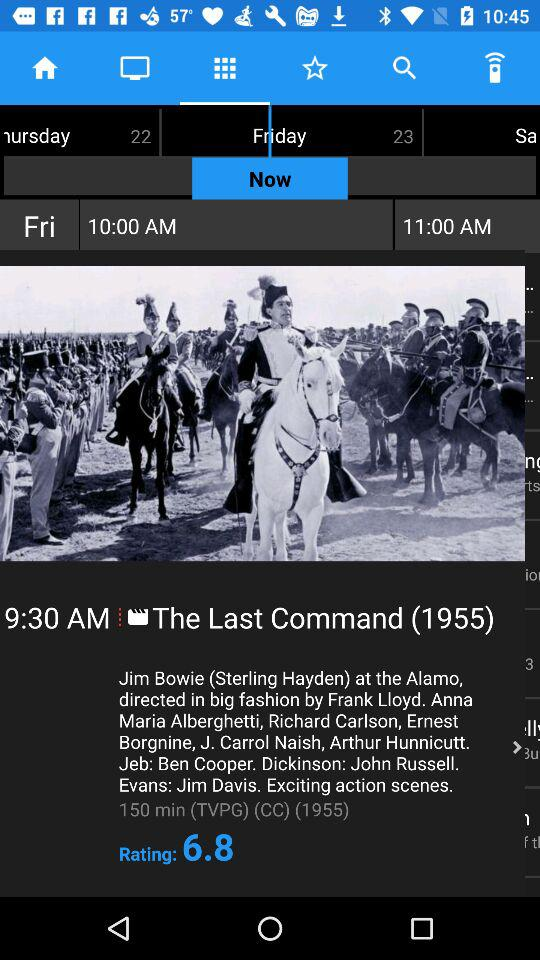Which day is mentioned? The mentioned day is Friday. 